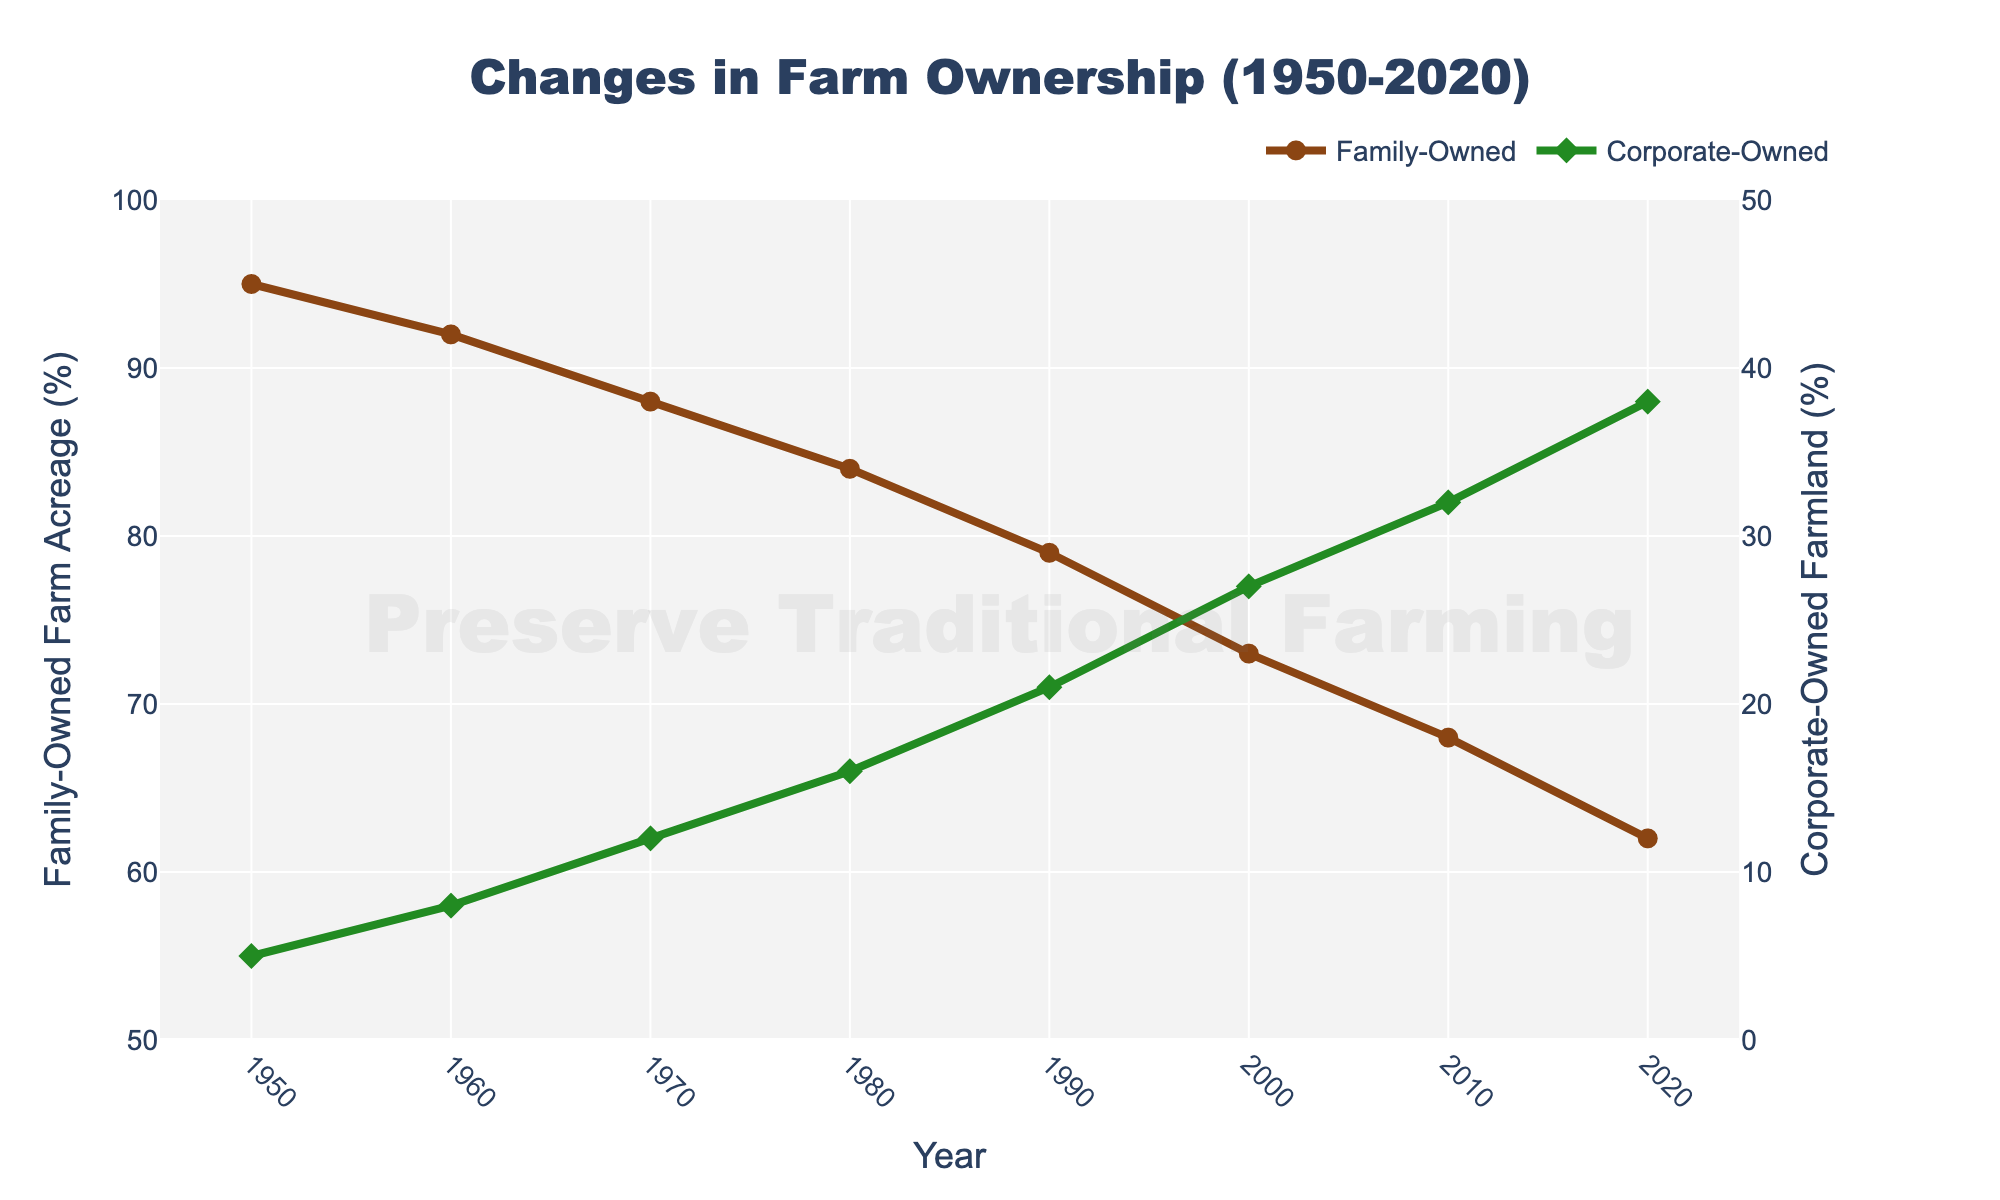What's the percentage change in family-owned farm acreage between 1950 and 2020? The percentage change can be calculated by finding the difference between the percentages in 1950 and 2020 and then dividing by the percentage in 1950. The difference is 95% - 62% = 33%. Therefore, the percentage change is (33/95) * 100%.
Answer: 34.74% In which year do corporate-owned farmlands surpass 20% for the first time? By inspecting the corporate-owned farmland data, it is evident that 21% is observed in 1990, which is the first year to surpass 20%.
Answer: 1990 How much wider is the gap between family-owned and corporate-owned farmland in 1950 compared to 2020? The gap in 1950 is 95% - 5% = 90%. The gap in 2020 is 62% - 38% = 24%. The difference in gaps is 90% - 24% = 66%.
Answer: 66% Between which consecutive decades is the steepest decline in family-owned farm acreage? By examining the family-owned acreage percentages, the steepest decline is between 1990 (79%) and 2000 (73%). The difference is 79% - 73% = 6%.
Answer: Between 1990 and 2000 What is the difference in the percentage of family-owned farm acreage between 1970 and 1980? The figure shows that in 1970, the percentage is 88%, and in 1980, it is 84%. The difference is 88% - 84% = 4%.
Answer: 4% What is the total percentage of corporate-owned farmland in the years when it is above 20%? The years with corporate-owned farmland above 20% are 1990 (21%), 2000 (27%), 2010 (32%), and 2020 (38%). Summing these values, 21 + 27 + 32 + 38 = 118%.
Answer: 118% Which type of farm ownership exhibits a steeper visual slope in the line chart from 1950 to 2020? Comparing the slopes of the family-owned and corporate-owned lines, the steeper visual slope is for corporate-owned land, as it rises from 5% to 38%, whereas family-owned farmland decreases from 95% to 62%.
Answer: Corporate-owned How many years does it take for the percentage of corporate-owned farmland to increase by approximately 30% from 1950? Reviewing the data, in 1950, corporate-owned farmland is 5%. It reaches around 35% in 2010 (38%). Therefore, it takes approximately 60 years (1950-2010).
Answer: 60 years What's the average percentage of family-owned farm acreage from 1950 to 2020? Summing the percentages from 1950 to 2020 (95 + 92 + 88 + 84 + 79 + 73 + 68 + 62) gives 641. Dividing by the number of data points (8) results in 641/8 = 80.125%.
Answer: 80.125% In what year do family-owned and corporate-owned farmland's combined percentage reach 100%? Observing the chart, every year from 1950 to 2020 has the combined percentage reaching 100%. This is consistent throughout the entire period.
Answer: Every year from 1950 to 2020 